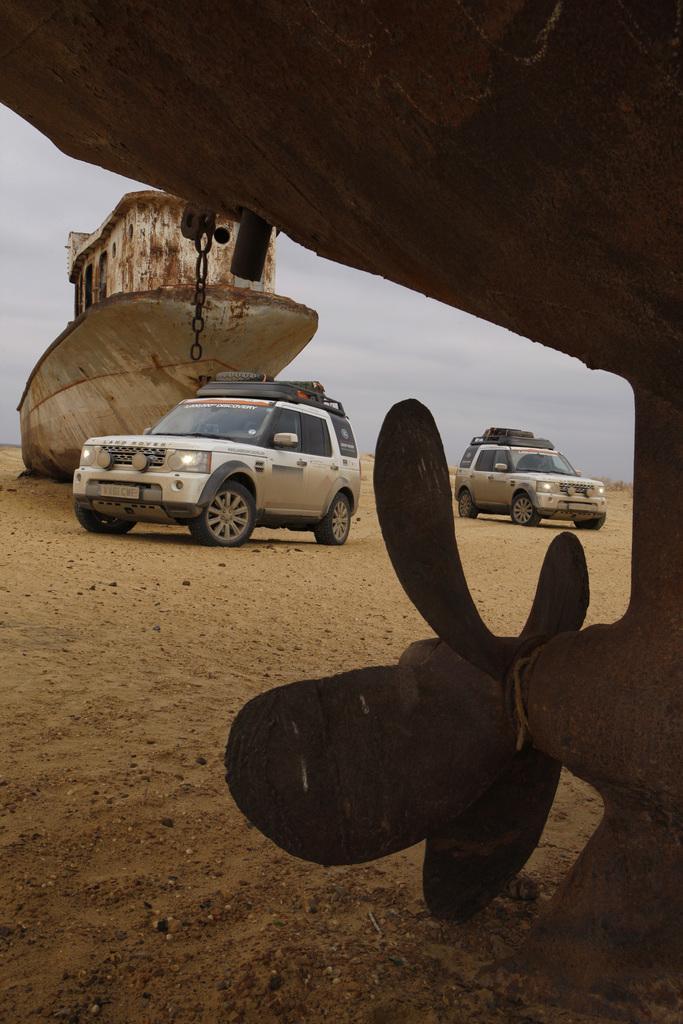Can you describe this image briefly? In this picture we can see two car near to the white ship. On the right there is a propeller fan. In the background we can see sky and clouds. On the right there is a sand. 